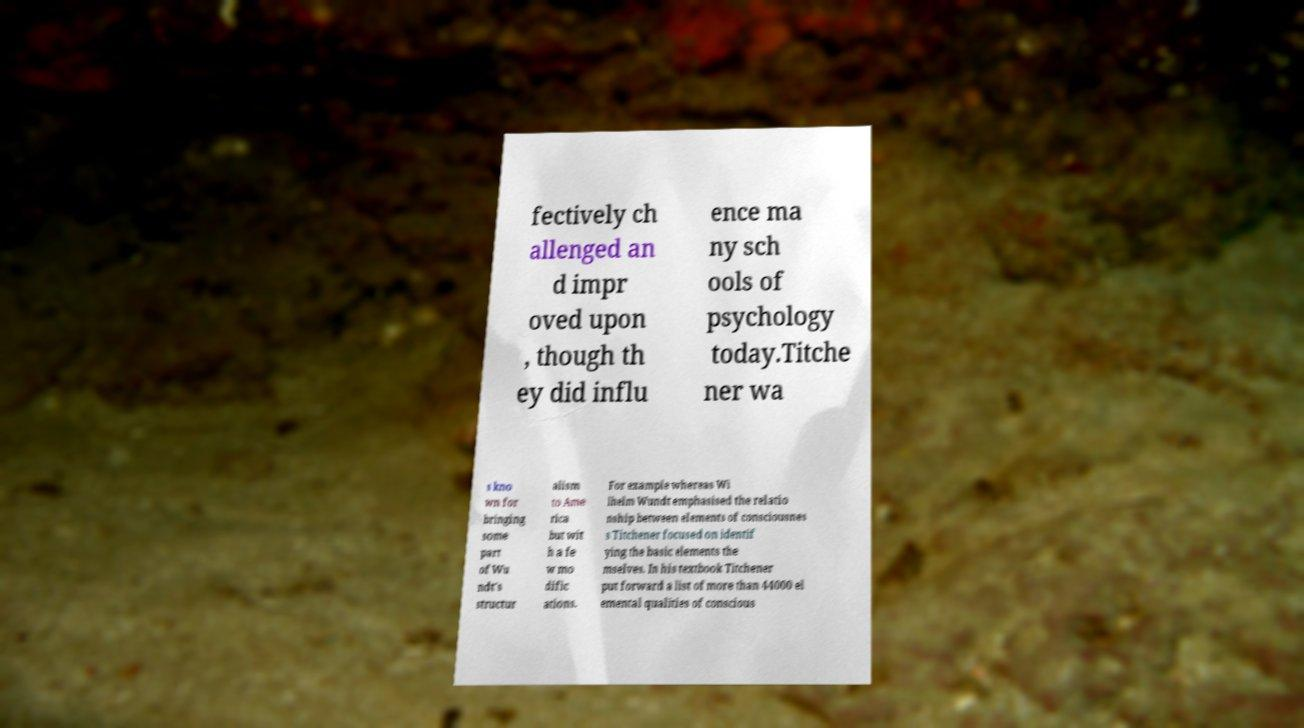Please identify and transcribe the text found in this image. fectively ch allenged an d impr oved upon , though th ey did influ ence ma ny sch ools of psychology today.Titche ner wa s kno wn for bringing some part of Wu ndt's structur alism to Ame rica but wit h a fe w mo dific ations. For example whereas Wi lhelm Wundt emphasised the relatio nship between elements of consciousnes s Titchener focused on identif ying the basic elements the mselves. In his textbook Titchener put forward a list of more than 44000 el emental qualities of conscious 